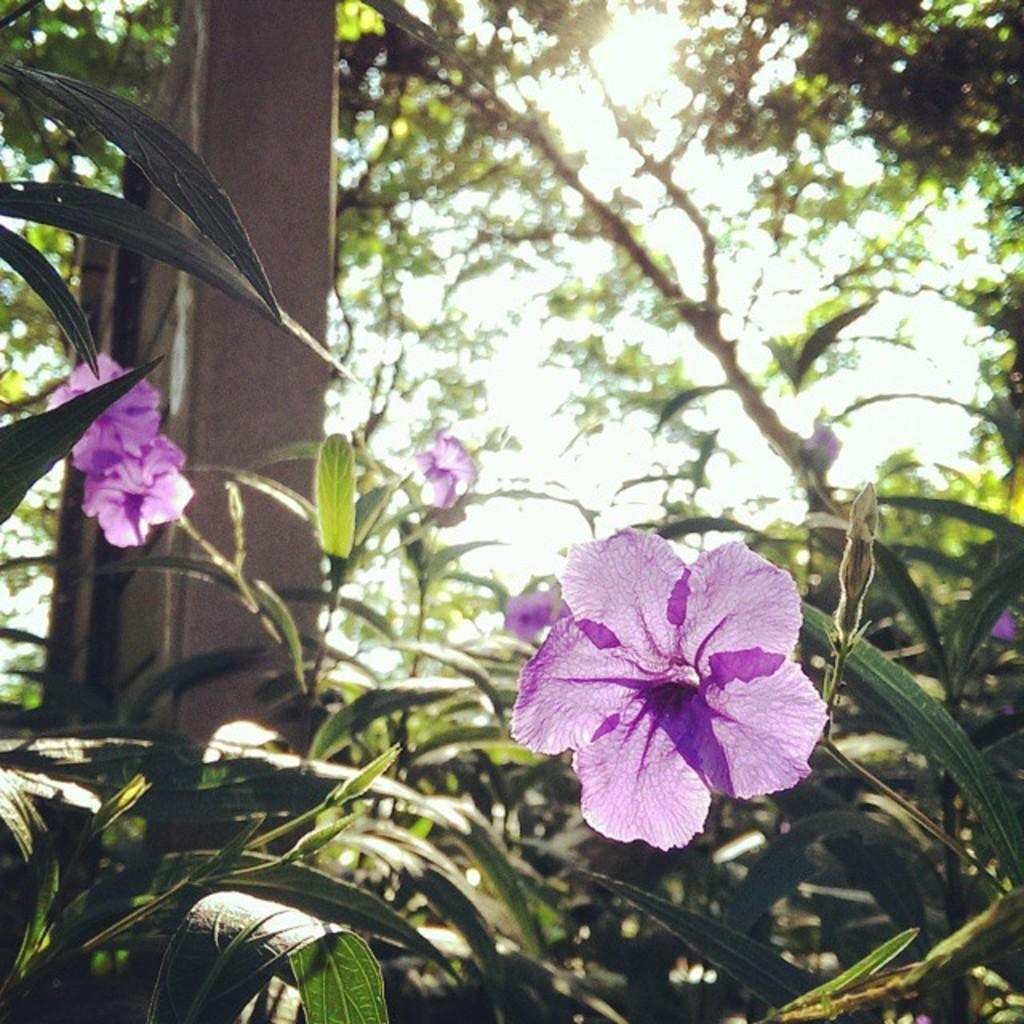What type of plants can be seen in the image? There are plants with flowers and leaves in the image. What color are the flowers on the plants? The flowers are purple in color. What can be seen in the background of the image? There are trees and a board visible in the background of the image. How many pizzas are being held by the plants in the image? There are no pizzas present in the image; it features plants with flowers and leaves. What type of muscle is visible on the plants in the image? Plants do not have muscles, so there is no muscle visible on the plants in the image. 